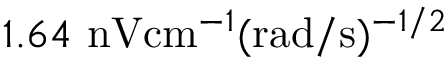Convert formula to latex. <formula><loc_0><loc_0><loc_500><loc_500>1 . 6 4 \ n V c m ^ { - 1 } ( r a d / s ) ^ { - 1 / 2 }</formula> 